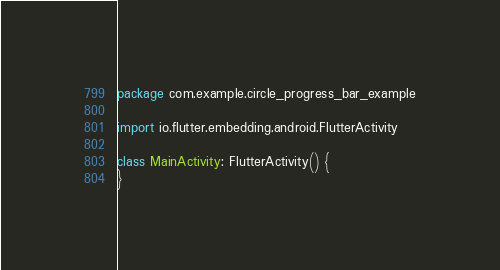<code> <loc_0><loc_0><loc_500><loc_500><_Kotlin_>package com.example.circle_progress_bar_example

import io.flutter.embedding.android.FlutterActivity

class MainActivity: FlutterActivity() {
}
</code> 